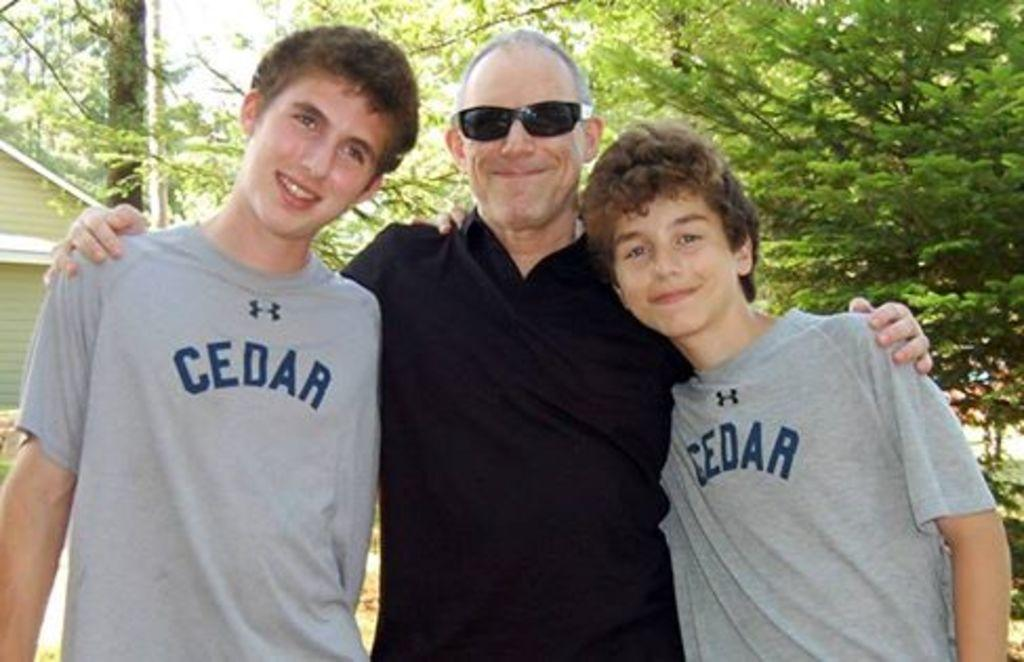How many people are present in the image? There are three people in the image. What are the people doing in the image? The people are standing in front of a tree and looking and smiling at someone or something. Can you describe the location of the people in relation to the tree? The people are standing in front of the tree. What type of jeans is the tree wearing in the image? The tree is not a person and therefore cannot wear jeans or any other clothing. 